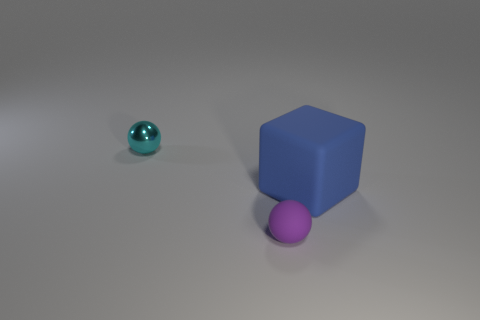Is there any other thing that has the same material as the cyan thing?
Keep it short and to the point. No. Is the size of the object behind the blue cube the same as the small rubber object?
Provide a short and direct response. Yes. What number of large brown spheres are there?
Your answer should be very brief. 0. What number of spheres are purple rubber things or small metallic things?
Ensure brevity in your answer.  2. What number of small purple rubber spheres are in front of the tiny sphere left of the tiny purple thing?
Make the answer very short. 1. Is the big blue block made of the same material as the purple ball?
Keep it short and to the point. Yes. Is there a large blue object that has the same material as the purple thing?
Give a very brief answer. Yes. There is a ball that is left of the ball that is on the right side of the tiny thing behind the purple ball; what is its color?
Your answer should be very brief. Cyan. What number of blue objects are metallic things or balls?
Offer a very short reply. 0. What number of other blue matte things have the same shape as the big blue thing?
Offer a very short reply. 0. 